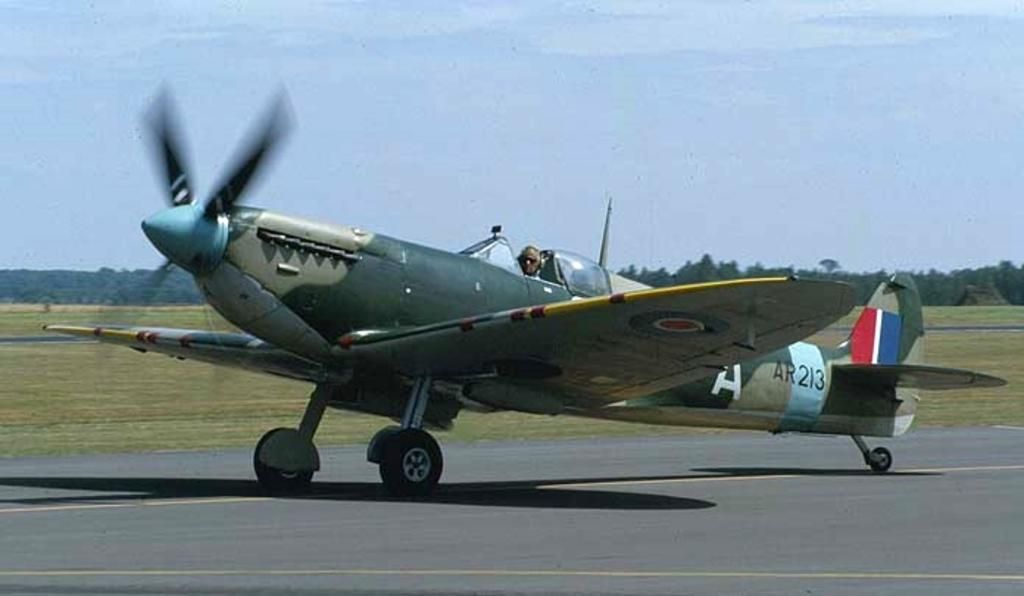<image>
Describe the image concisely. An AR 213 with red,white, and blue on its tail is getting ready for takeoff 